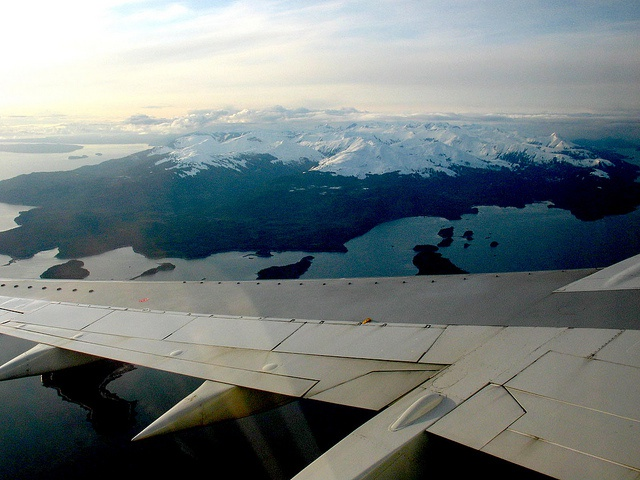Describe the objects in this image and their specific colors. I can see a airplane in white, gray, darkgray, and black tones in this image. 